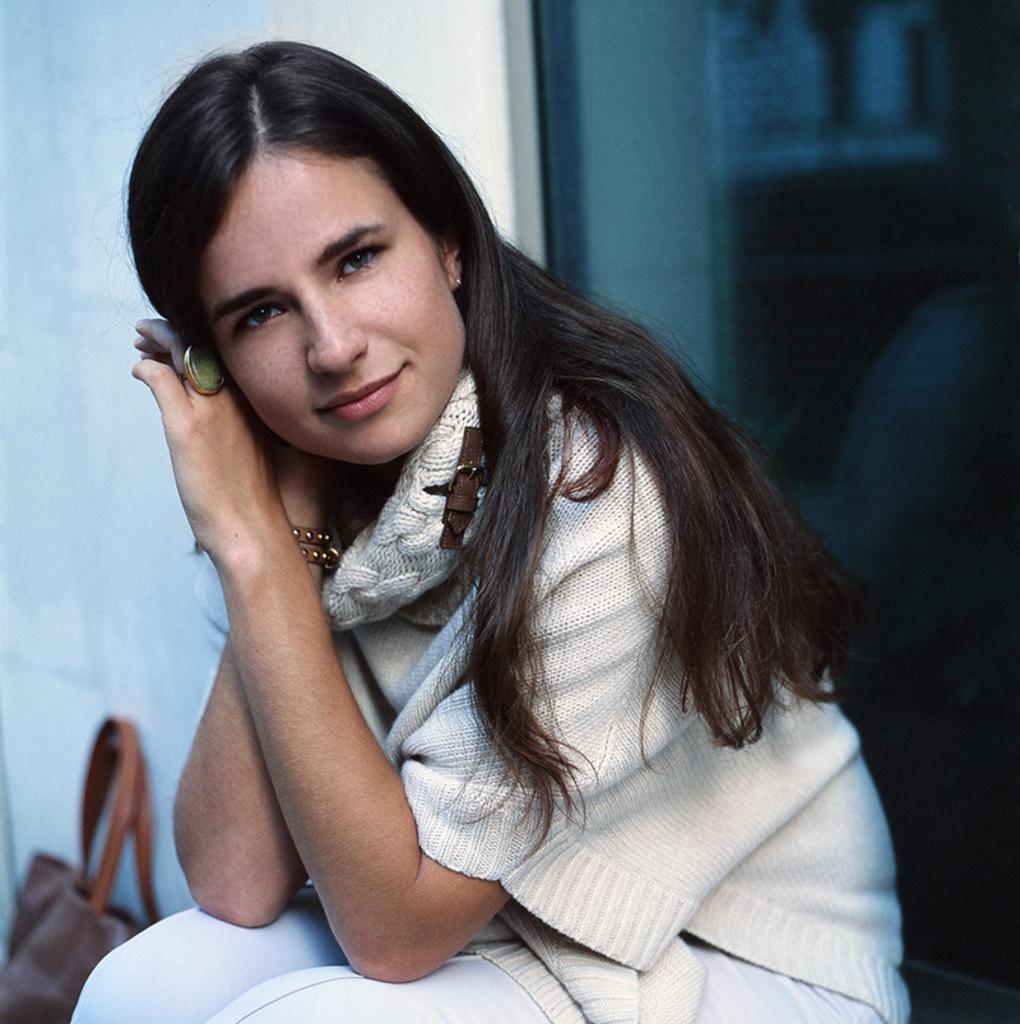Could you give a brief overview of what you see in this image? In this picture we can see a woman sitting, side we can see bag. 